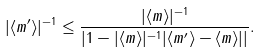Convert formula to latex. <formula><loc_0><loc_0><loc_500><loc_500>| \langle m ^ { \prime } \rangle | ^ { - 1 } \leq \frac { | \langle m \rangle | ^ { - 1 } } { \left | 1 - | \langle m \rangle | ^ { - 1 } | \langle m ^ { \prime } \rangle - \langle m \rangle | \right | } .</formula> 